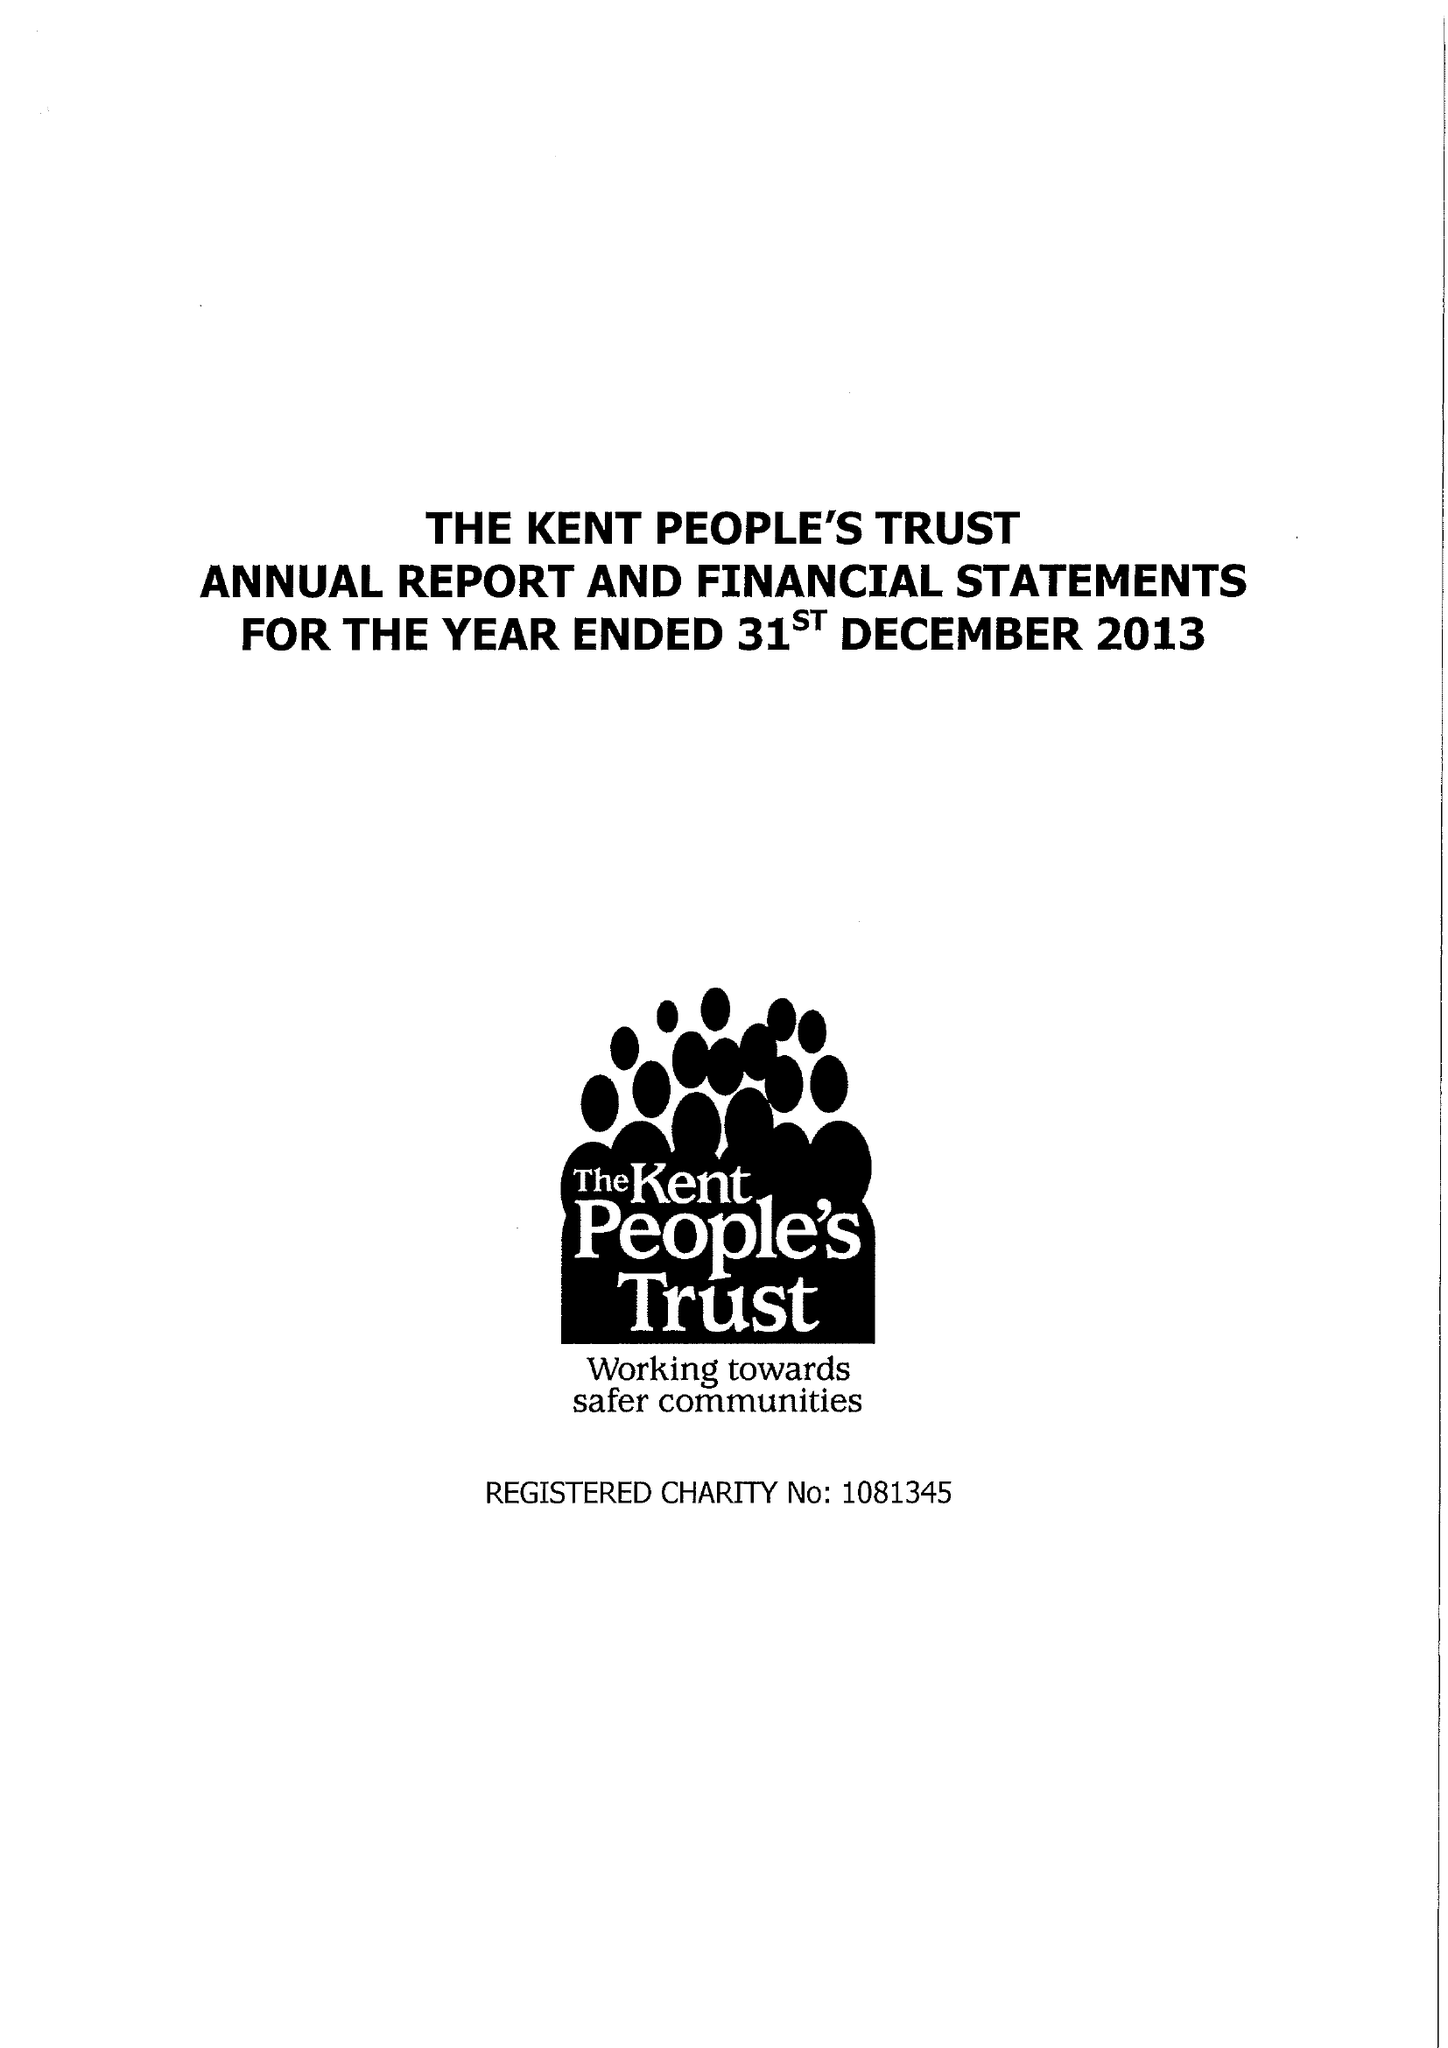What is the value for the report_date?
Answer the question using a single word or phrase. 2013-12-31 